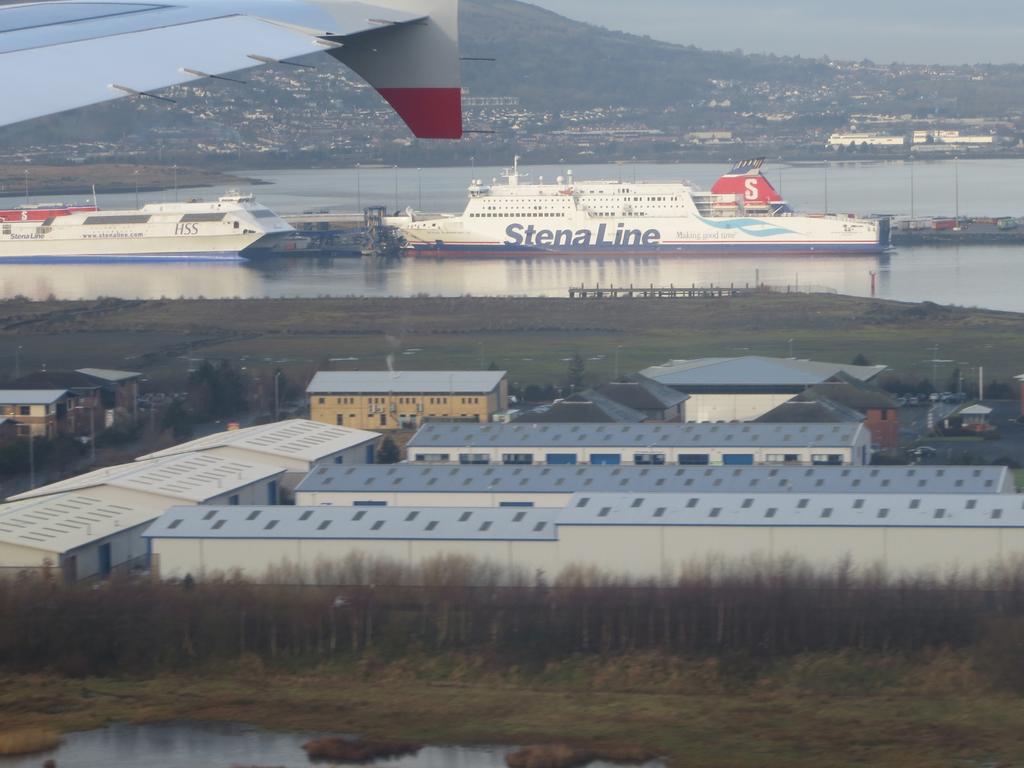What is the name on the side of the boat?
Offer a terse response. Stena line. What is the name of the boat in the rear?
Ensure brevity in your answer.  Stena line. 